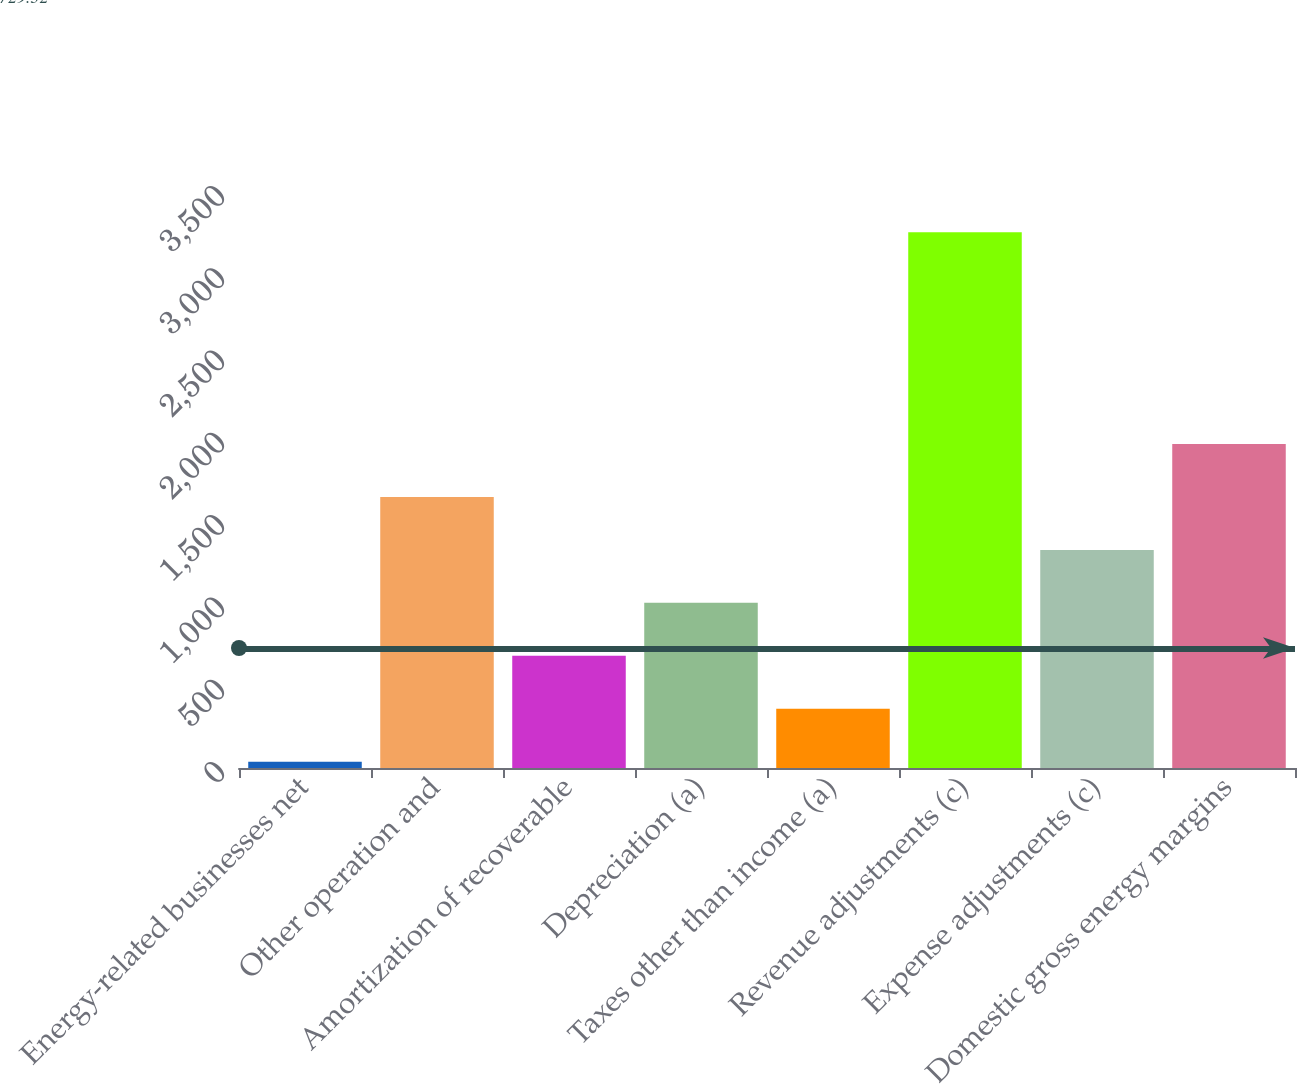Convert chart. <chart><loc_0><loc_0><loc_500><loc_500><bar_chart><fcel>Energy-related businesses net<fcel>Other operation and<fcel>Amortization of recoverable<fcel>Depreciation (a)<fcel>Taxes other than income (a)<fcel>Revenue adjustments (c)<fcel>Expense adjustments (c)<fcel>Domestic gross energy margins<nl><fcel>38<fcel>1647<fcel>681.6<fcel>1003.4<fcel>359.8<fcel>3256<fcel>1325.2<fcel>1968.8<nl></chart> 